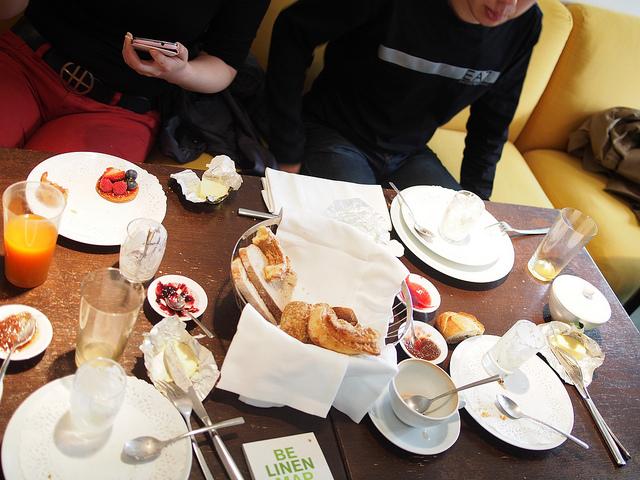Is there a salad on one of the plates?
Concise answer only. No. Is this a breakfast table?
Answer briefly. Yes. Is this a breakfast meal?
Give a very brief answer. Yes. What color are the dishes?
Write a very short answer. White. Is one of the glasses half full of orange juice?
Be succinct. Yes. How many empty plates in the picture?
Answer briefly. 4. How many place settings?
Quick response, please. 4. Where is this?
Concise answer only. Restaurant. 